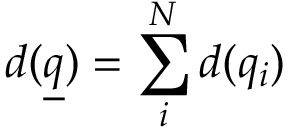Convert formula to latex. <formula><loc_0><loc_0><loc_500><loc_500>d ( \underline { q } ) = \sum _ { i } ^ { N } d ( q _ { i } )</formula> 